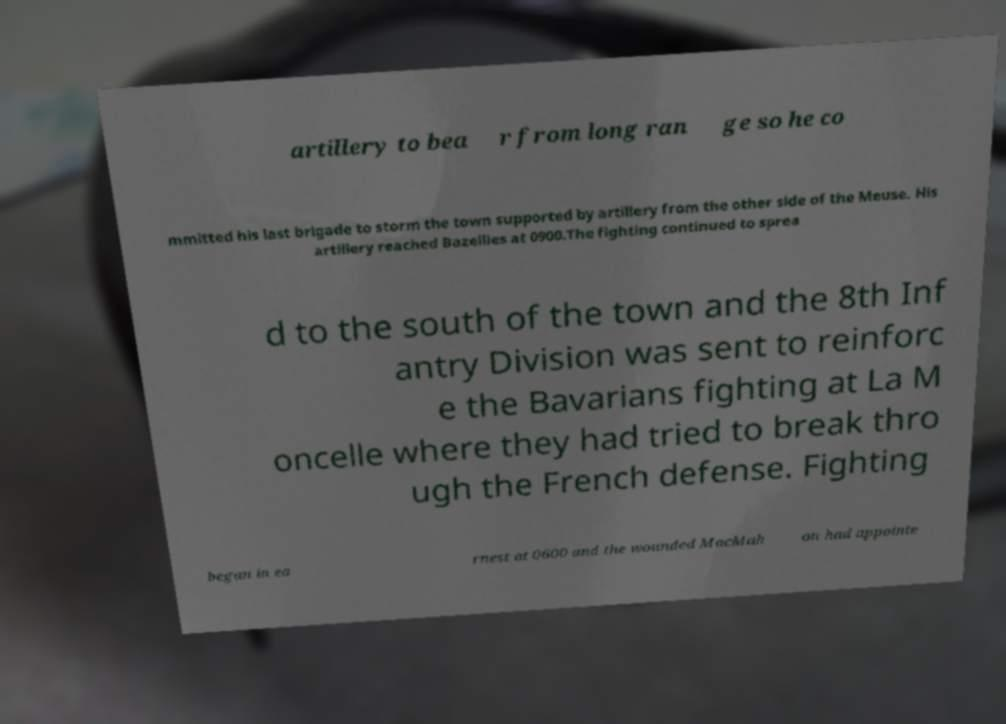Can you read and provide the text displayed in the image?This photo seems to have some interesting text. Can you extract and type it out for me? artillery to bea r from long ran ge so he co mmitted his last brigade to storm the town supported by artillery from the other side of the Meuse. His artillery reached Bazeilles at 0900.The fighting continued to sprea d to the south of the town and the 8th Inf antry Division was sent to reinforc e the Bavarians fighting at La M oncelle where they had tried to break thro ugh the French defense. Fighting began in ea rnest at 0600 and the wounded MacMah on had appointe 